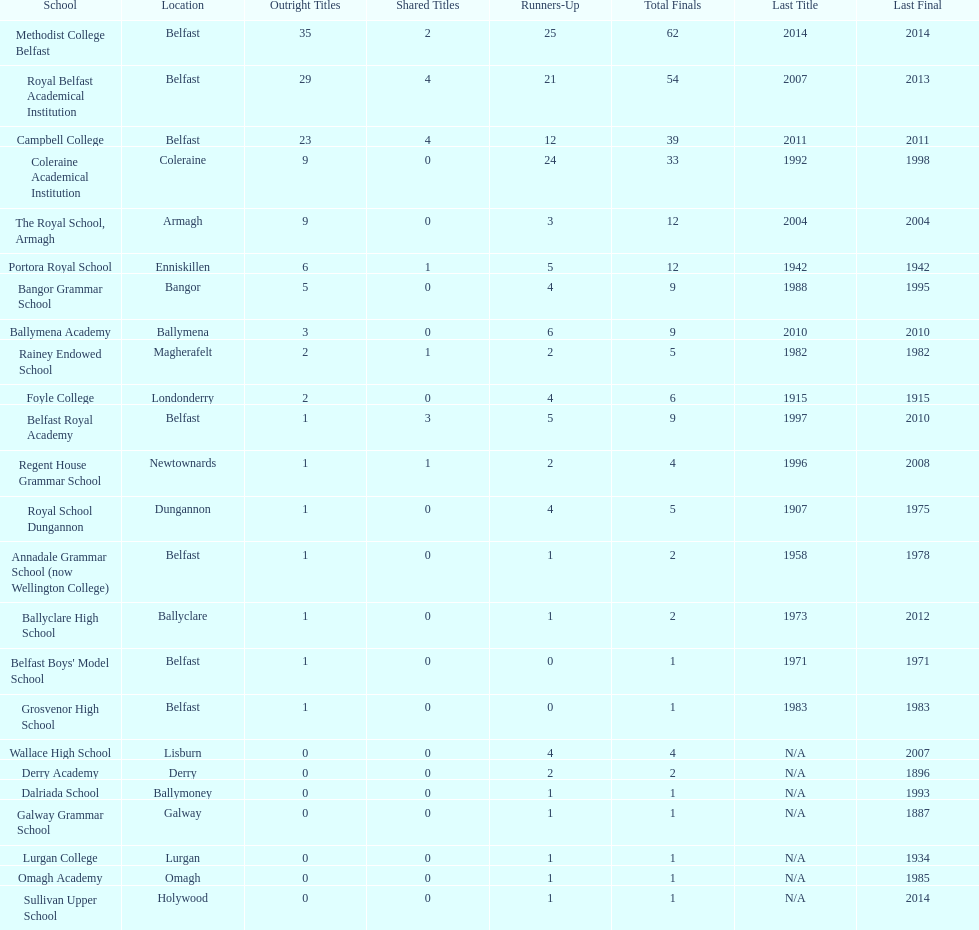Who has the most recent title win, campbell college or regent house grammar school? Campbell College. 